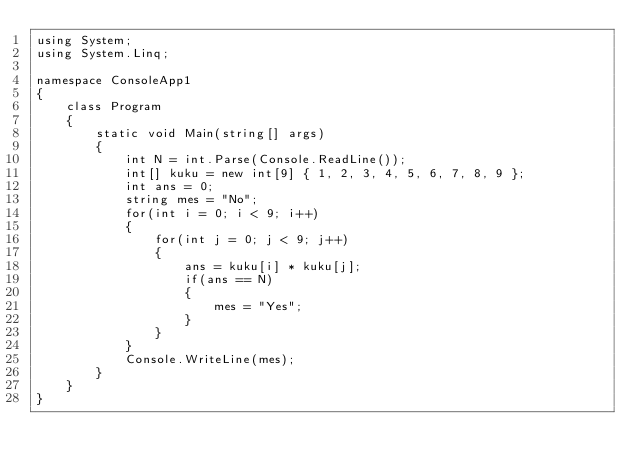Convert code to text. <code><loc_0><loc_0><loc_500><loc_500><_C#_>using System;
using System.Linq;

namespace ConsoleApp1
{
    class Program
    {
        static void Main(string[] args)
        {
            int N = int.Parse(Console.ReadLine());
            int[] kuku = new int[9] { 1, 2, 3, 4, 5, 6, 7, 8, 9 };
            int ans = 0;
            string mes = "No";
            for(int i = 0; i < 9; i++)
            {
                for(int j = 0; j < 9; j++)
                {
                    ans = kuku[i] * kuku[j];
                    if(ans == N)
                    {
                        mes = "Yes";
                    }
                }
            }
            Console.WriteLine(mes);
        }
    }
}</code> 